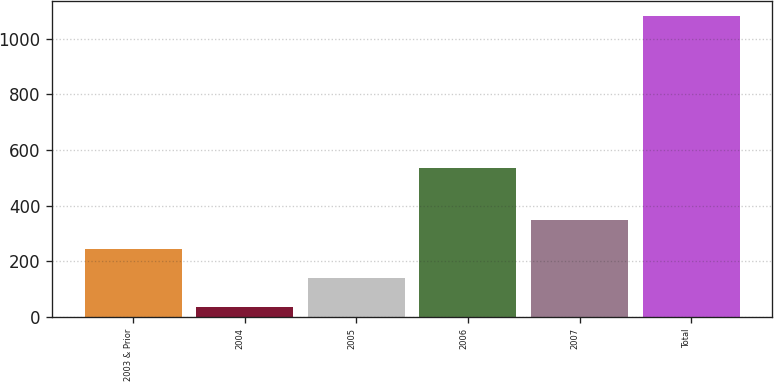<chart> <loc_0><loc_0><loc_500><loc_500><bar_chart><fcel>2003 & Prior<fcel>2004<fcel>2005<fcel>2006<fcel>2007<fcel>Total<nl><fcel>244.8<fcel>35<fcel>139.9<fcel>536<fcel>349.7<fcel>1084<nl></chart> 